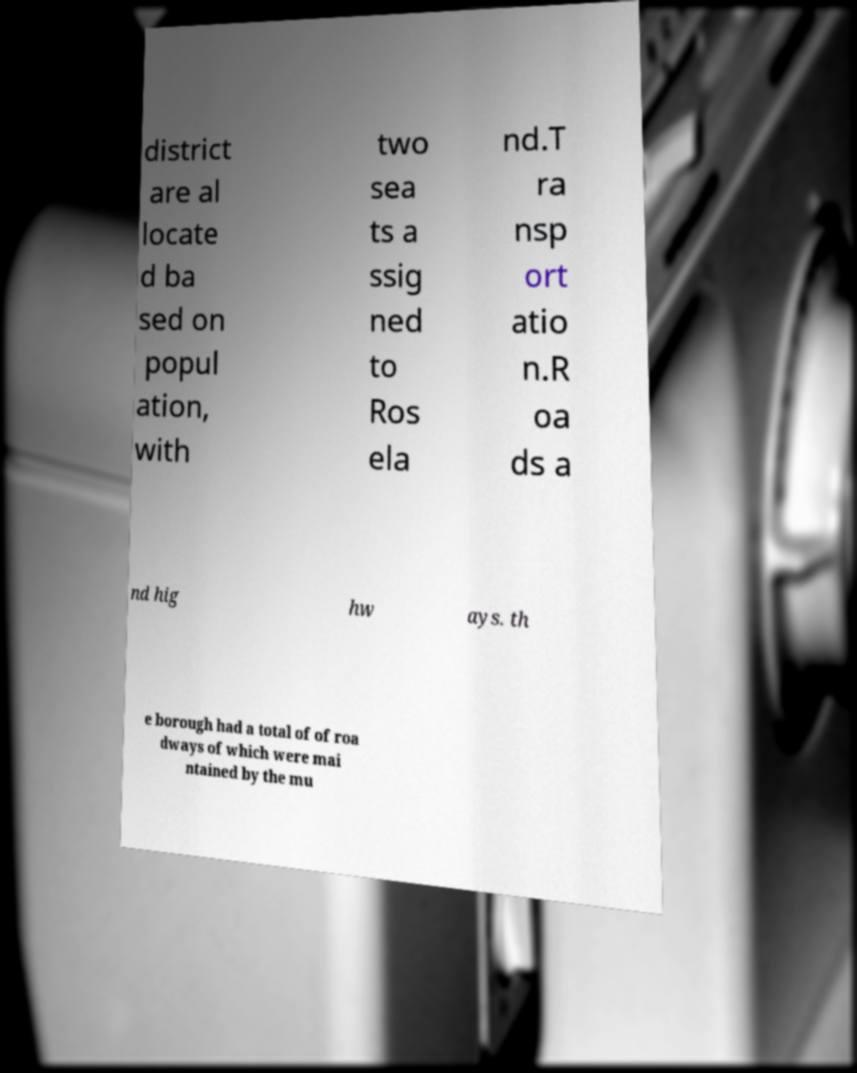Could you extract and type out the text from this image? district are al locate d ba sed on popul ation, with two sea ts a ssig ned to Ros ela nd.T ra nsp ort atio n.R oa ds a nd hig hw ays. th e borough had a total of of roa dways of which were mai ntained by the mu 